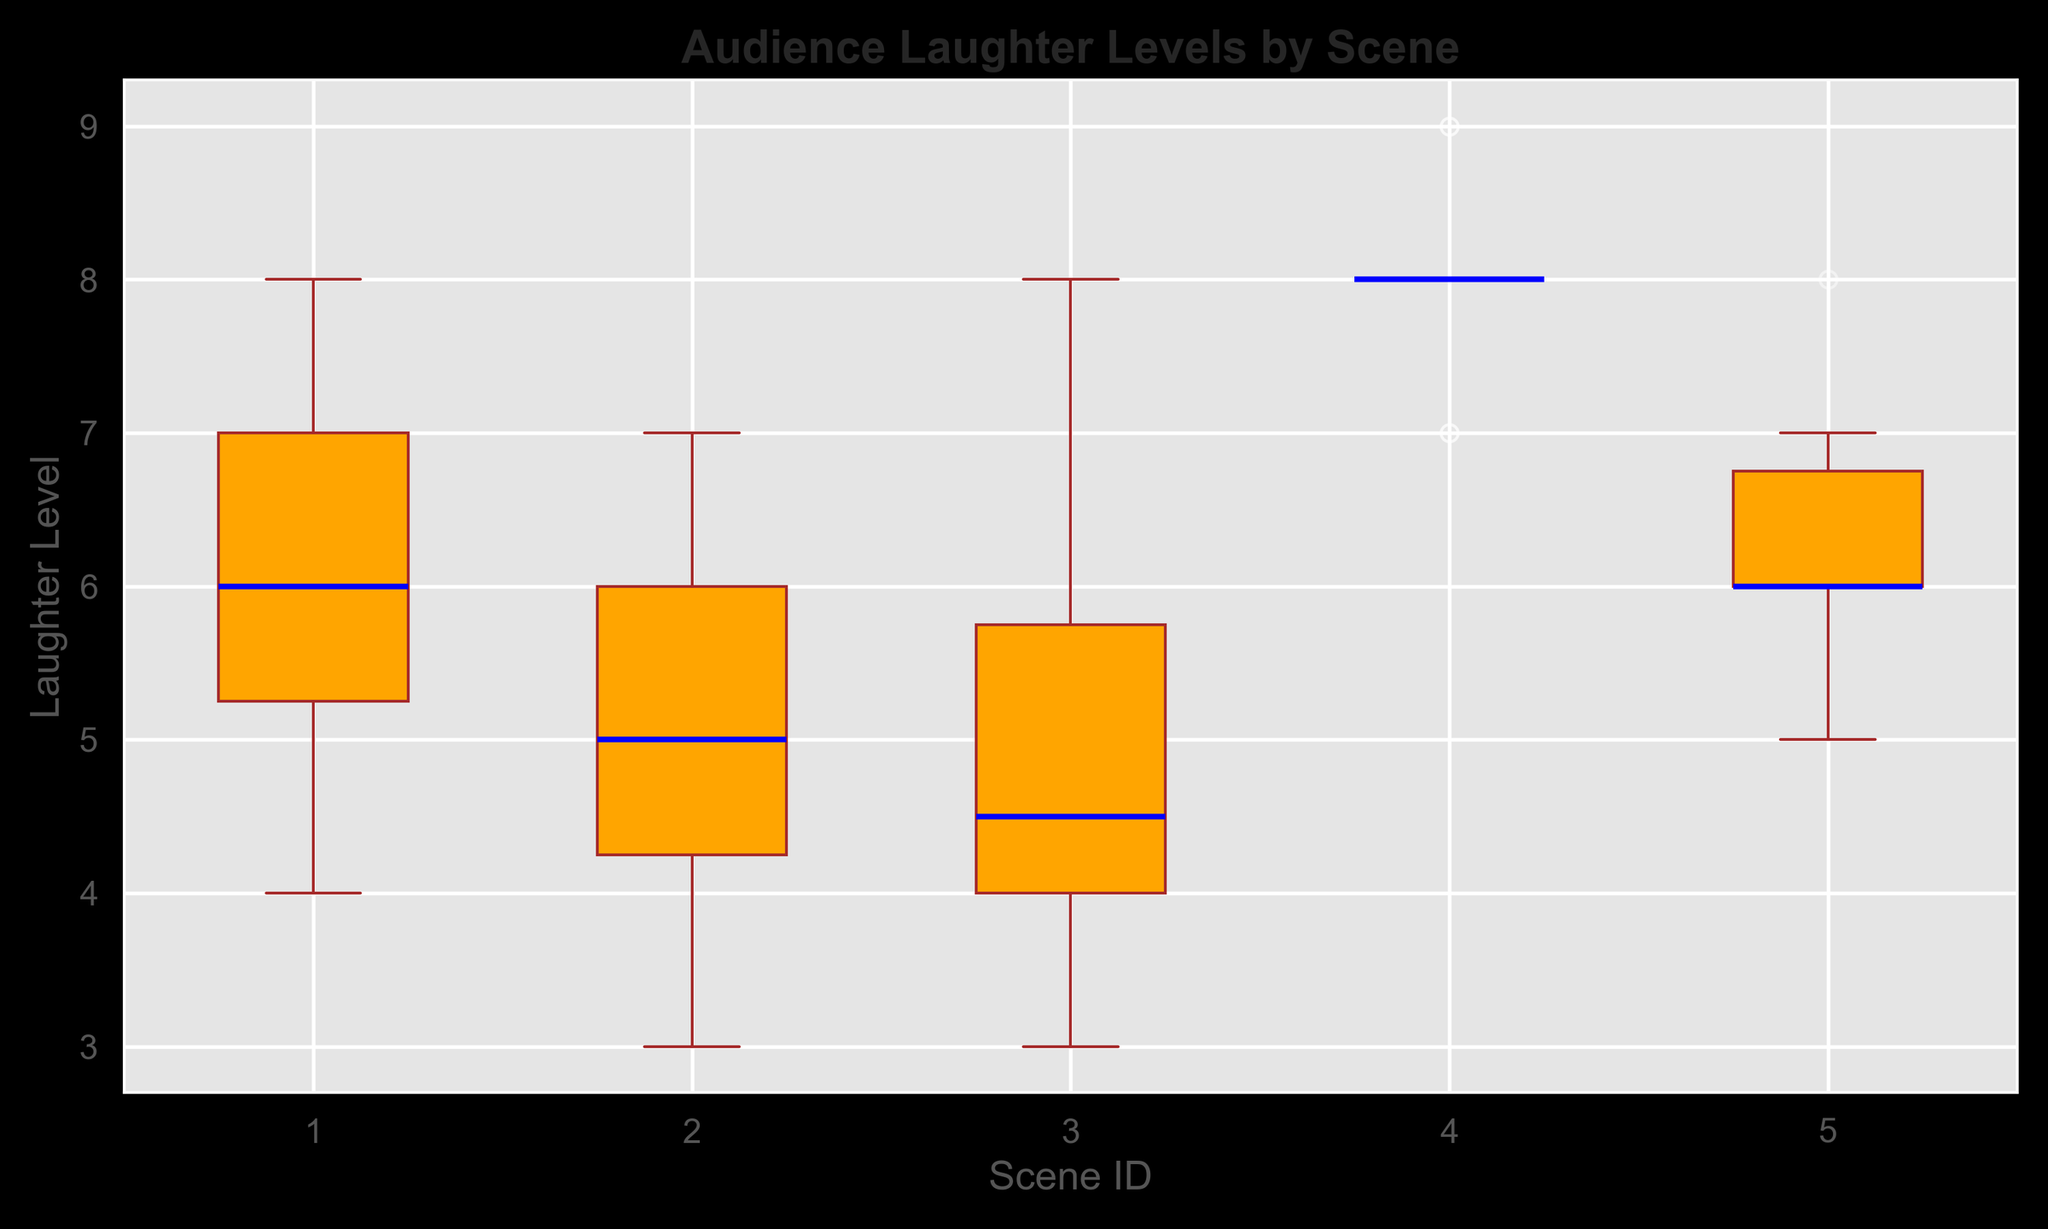What is the median laughter level for Scene 1? The blue line in the box for Scene 1 indicates the median laughter level. By observing the box plot, you can find this value.
Answer: 6 Which scene has the highest median laughter level? To determine the scene with the highest median laughter level, look for the highest blue line in any of the boxes.
Answer: Scene 4 What is the range of laughter levels for Scene 2? The range can be found by subtracting the lowest whisker value from the highest whisker value for Scene 2.
Answer: 3 Which scenes have overlapping interquartile ranges (IQR)? By comparing the boxes' vertical spans, you can see if there is a region of overlap between any of the scenes' IQRs. Scene 3 and Scene 5 both have similar ranges.
Answer: Scene 3 and 5 Is there any outlier in the laughter levels for any scene? Outliers are represented by individual points outside the whiskers. Check if there are any points distinctly separate from the whiskers.
Answer: No How does the spread of data in Scene 4 compare to Scene 1? Compare the width of the boxes and the length of the whiskers for both scenes. Scene 4 has a more compressed box, indicating less spread.
Answer: Scene 4 has less spread Which scene has the smallest interquartile range (IQR)? Check the height of the box within each box plot. The smallest box represents the smallest IQR.
Answer: Scene 4 What is the difference between the upper quartile of Scene 3 and the upper quartile of Scene 1? Identify the top edge of the boxes for Scene 3 and Scene 1, then subtract the value of Scene 1's upper quartile from Scene 3’s upper quartile value.
Answer: 2 (7 - 5) How many scenes have a median laughter level equal to 6? Find the blue line in each plot and count how many are at level 6. In this case, observe Scene 1, Scene 2, and Scene 5.
Answer: 3 Do any scenes have identical medians, and if so, which ones? Compare the blue lines across all scenes to check for the same median levels.
Answer: Scene 1, Scene 2, and Scene 5 